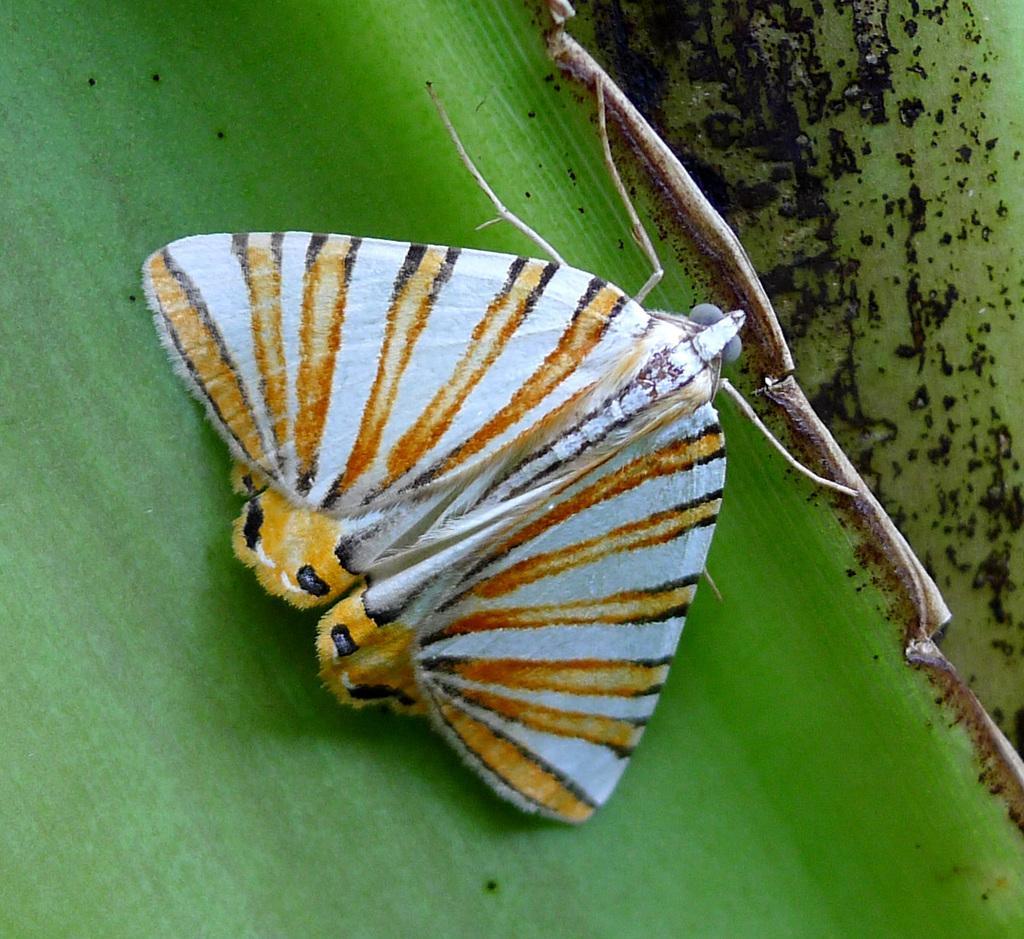Can you describe this image briefly? In this picture we can see a butterfly on a leaf. 